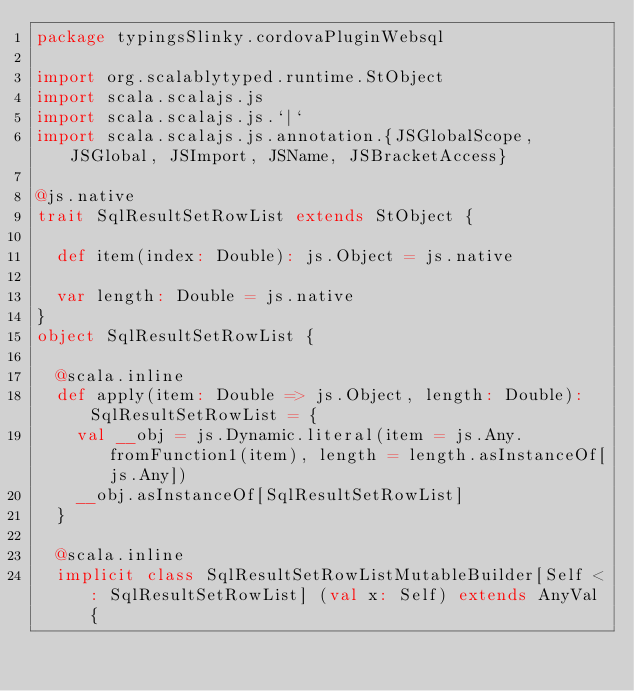<code> <loc_0><loc_0><loc_500><loc_500><_Scala_>package typingsSlinky.cordovaPluginWebsql

import org.scalablytyped.runtime.StObject
import scala.scalajs.js
import scala.scalajs.js.`|`
import scala.scalajs.js.annotation.{JSGlobalScope, JSGlobal, JSImport, JSName, JSBracketAccess}

@js.native
trait SqlResultSetRowList extends StObject {
  
  def item(index: Double): js.Object = js.native
  
  var length: Double = js.native
}
object SqlResultSetRowList {
  
  @scala.inline
  def apply(item: Double => js.Object, length: Double): SqlResultSetRowList = {
    val __obj = js.Dynamic.literal(item = js.Any.fromFunction1(item), length = length.asInstanceOf[js.Any])
    __obj.asInstanceOf[SqlResultSetRowList]
  }
  
  @scala.inline
  implicit class SqlResultSetRowListMutableBuilder[Self <: SqlResultSetRowList] (val x: Self) extends AnyVal {
    </code> 